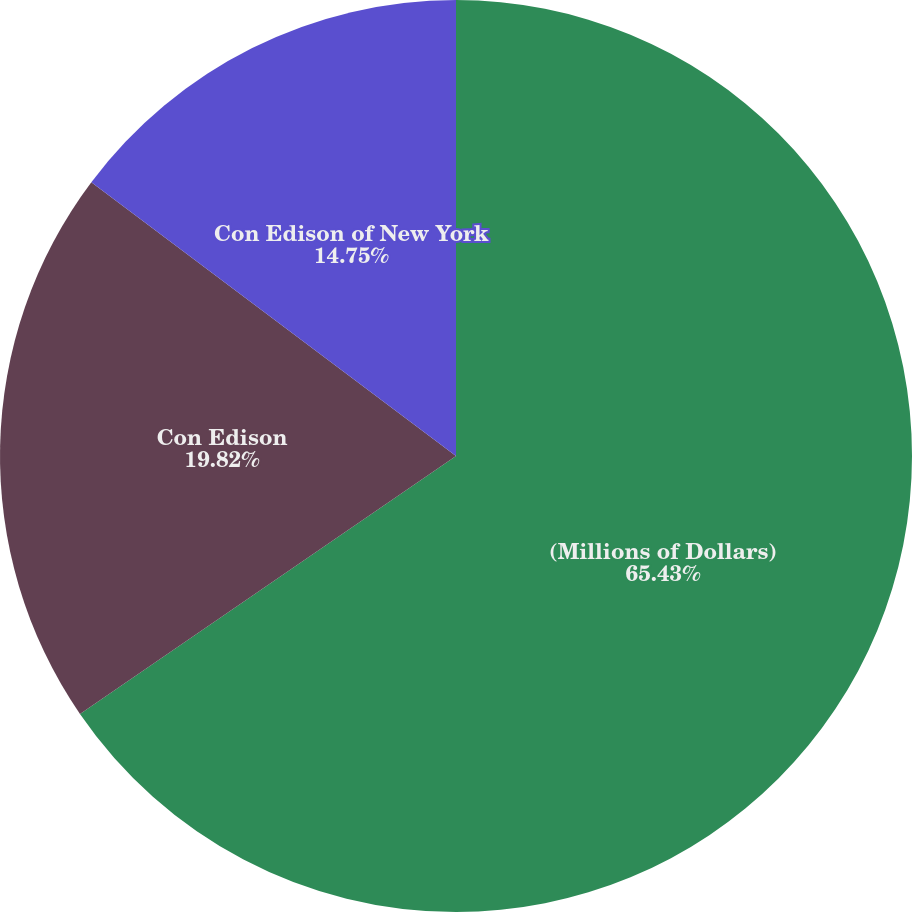Convert chart to OTSL. <chart><loc_0><loc_0><loc_500><loc_500><pie_chart><fcel>(Millions of Dollars)<fcel>Con Edison<fcel>Con Edison of New York<nl><fcel>65.43%<fcel>19.82%<fcel>14.75%<nl></chart> 